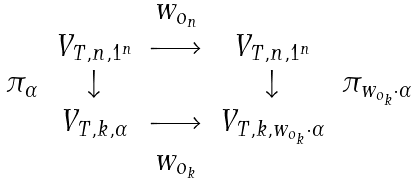Convert formula to latex. <formula><loc_0><loc_0><loc_500><loc_500>\begin{array} { c c c c c } & & w _ { o _ { n } } & & \\ & V _ { T , n , 1 ^ { n } } & \longrightarrow & V _ { T , n , 1 ^ { n } } & \\ \pi _ { \alpha } & \downarrow & & \downarrow & \pi _ { w _ { o _ { k } } \cdot \alpha } \\ & V _ { T , k , \alpha } & \longrightarrow & V _ { T , k , w _ { o _ { k } } \cdot \alpha } & \\ & & w _ { o _ { k } } & & \end{array}</formula> 